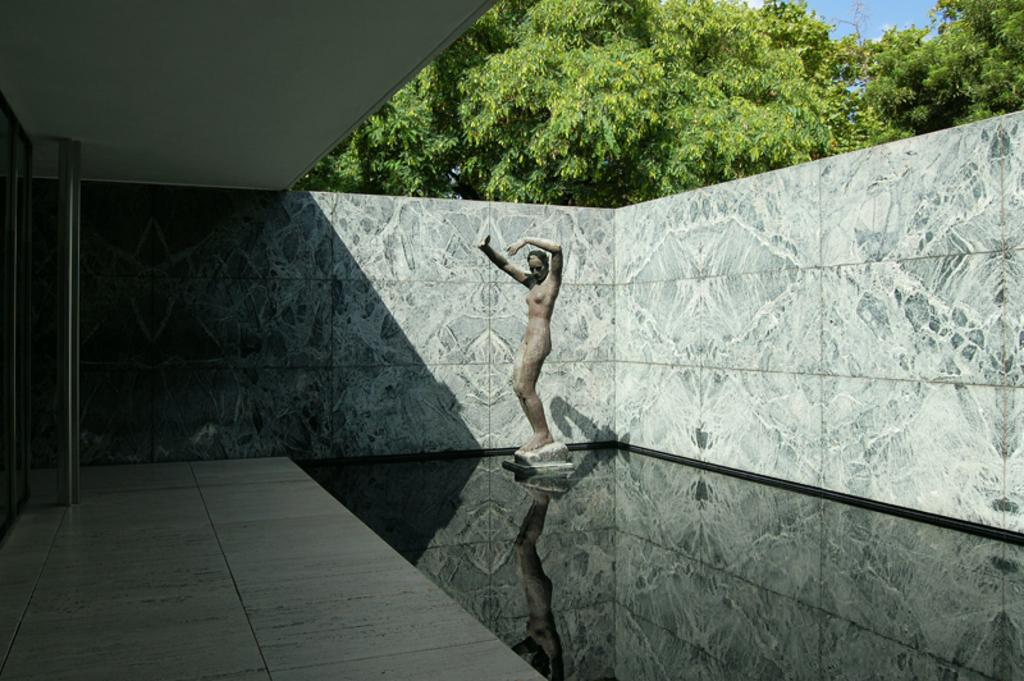What is the main subject of the image? There is a statue of a woman in the image. What is located at the base of the statue? There is water at the bottom of the statue. What can be seen in the background of the image? There is a wall and trees in the image. How many credit cards are visible in the image? There are no credit cards present in the image. Is there a bed in the image? There is no bed present in the image. 